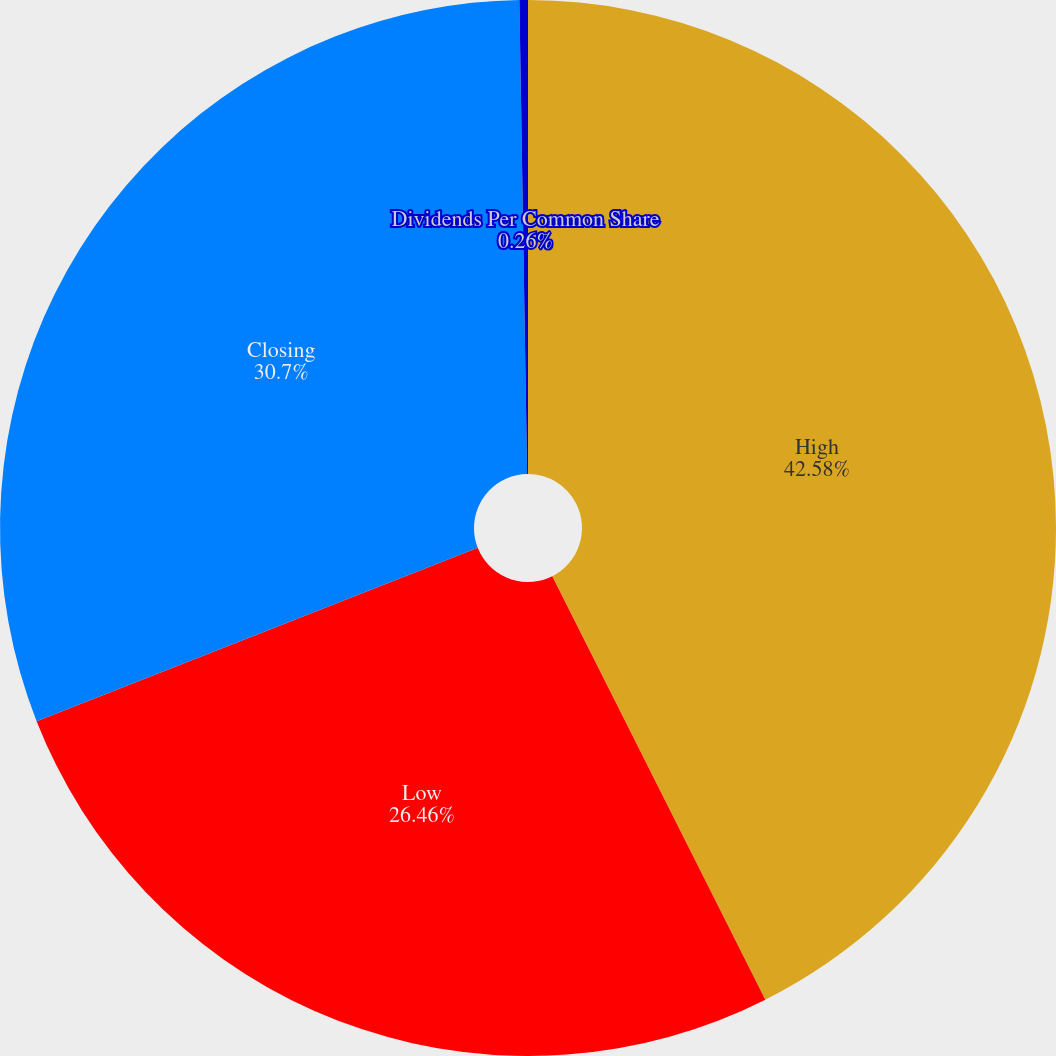Convert chart to OTSL. <chart><loc_0><loc_0><loc_500><loc_500><pie_chart><fcel>High<fcel>Low<fcel>Closing<fcel>Dividends Per Common Share<nl><fcel>42.58%<fcel>26.46%<fcel>30.7%<fcel>0.26%<nl></chart> 